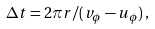Convert formula to latex. <formula><loc_0><loc_0><loc_500><loc_500>\Delta t = 2 \pi r / ( v _ { \phi } - u _ { \phi } ) \, ,</formula> 